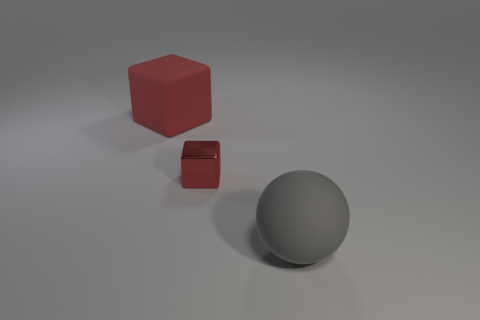What is the thing that is in front of the red rubber object and to the left of the big ball made of?
Offer a terse response. Metal. What shape is the large rubber object that is to the right of the big matte thing to the left of the gray sphere?
Your answer should be very brief. Sphere. Do the matte block and the big matte ball have the same color?
Provide a short and direct response. No. What number of gray objects are either large rubber cylinders or rubber balls?
Provide a succinct answer. 1. Are there any large red objects in front of the red metallic block?
Make the answer very short. No. How big is the red matte cube?
Your answer should be compact. Large. What size is the matte object that is the same shape as the metallic thing?
Ensure brevity in your answer.  Large. How many large gray objects are left of the red object in front of the red rubber thing?
Your response must be concise. 0. Is the red cube behind the metal block made of the same material as the small red block that is left of the gray matte object?
Your answer should be very brief. No. What number of tiny metallic things have the same shape as the red rubber object?
Your response must be concise. 1. 